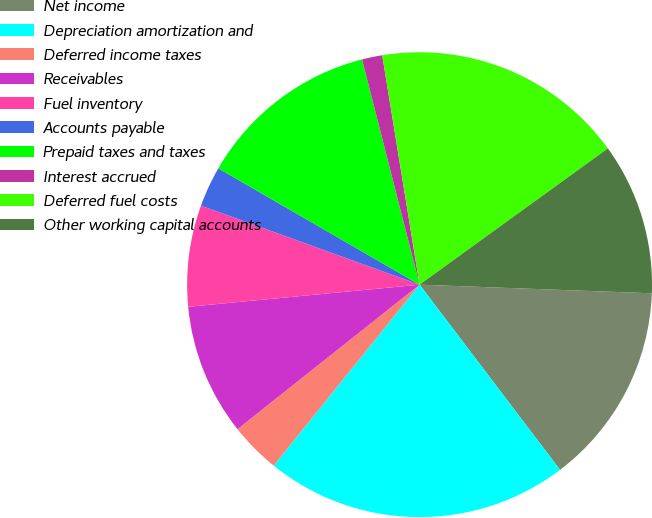<chart> <loc_0><loc_0><loc_500><loc_500><pie_chart><fcel>Net income<fcel>Depreciation amortization and<fcel>Deferred income taxes<fcel>Receivables<fcel>Fuel inventory<fcel>Accounts payable<fcel>Prepaid taxes and taxes<fcel>Interest accrued<fcel>Deferred fuel costs<fcel>Other working capital accounts<nl><fcel>14.08%<fcel>21.13%<fcel>3.52%<fcel>9.16%<fcel>7.04%<fcel>2.82%<fcel>12.68%<fcel>1.41%<fcel>17.6%<fcel>10.56%<nl></chart> 